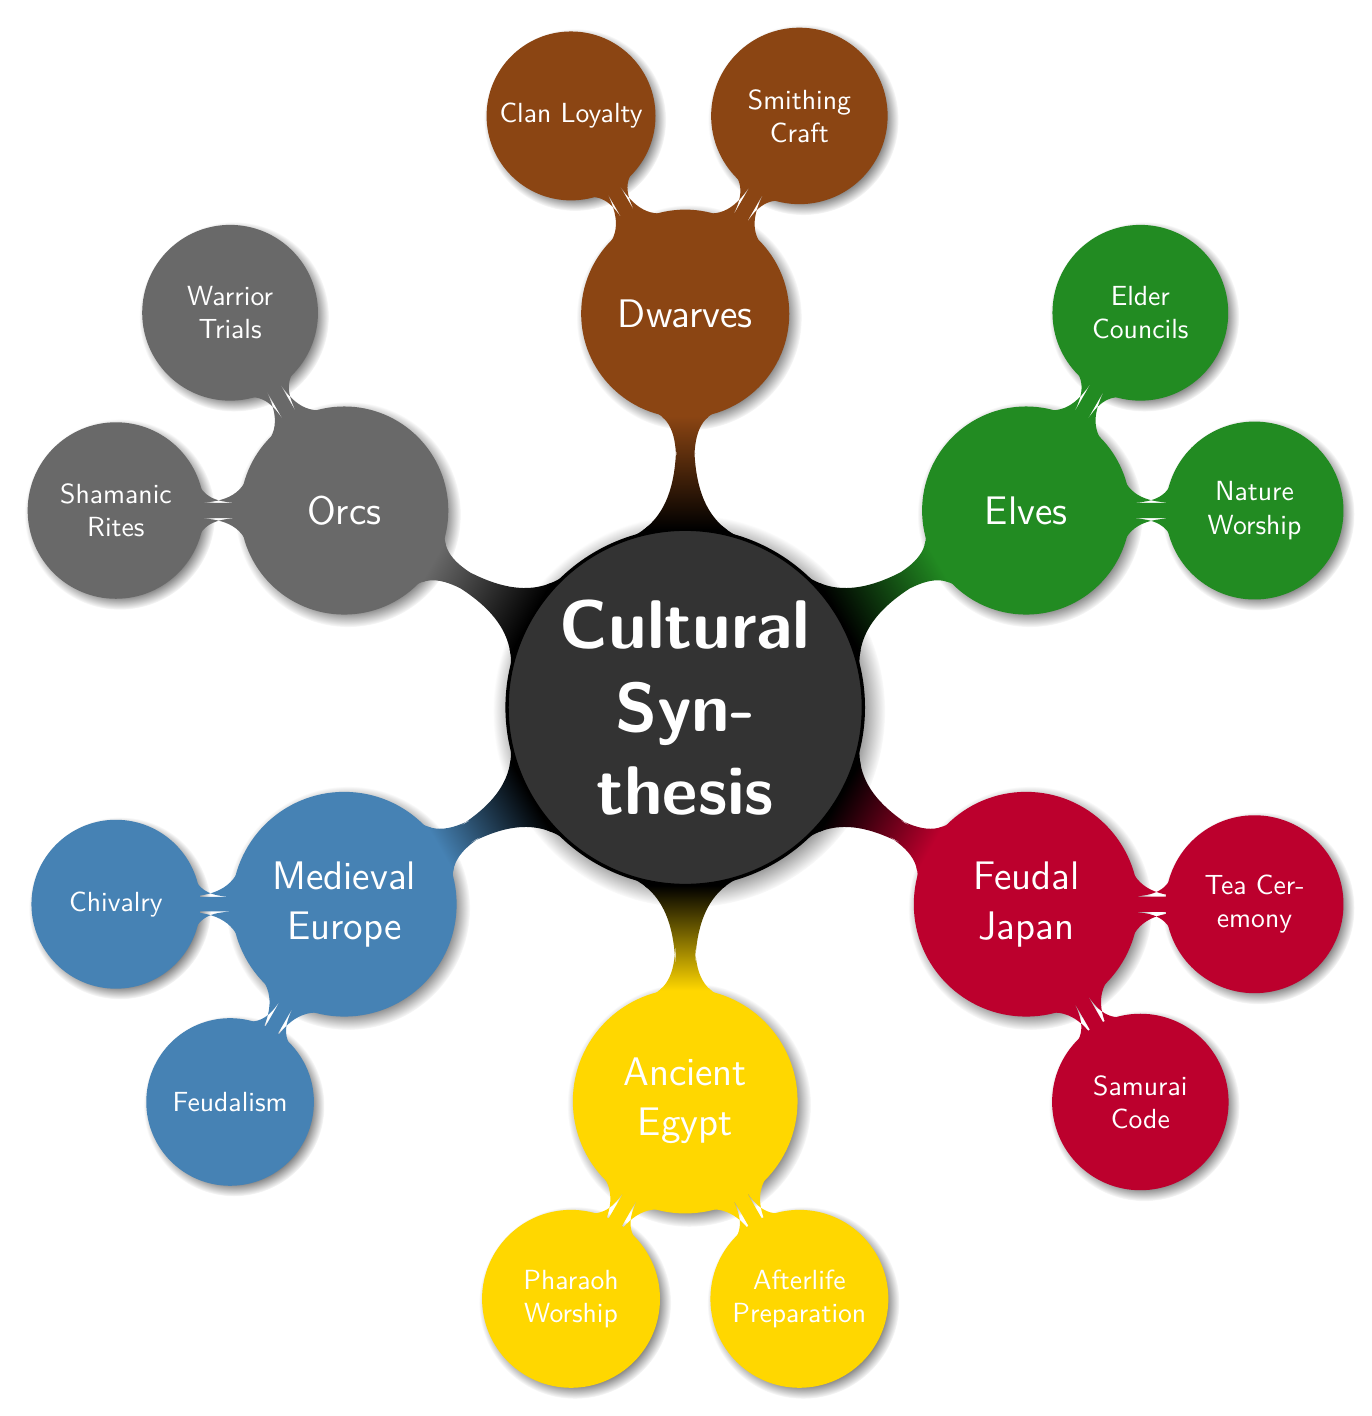What are the two traditions listed under Medieval Europe? The traditions listed under Medieval Europe in the diagram are "Chivalry" and "Feudalism," which can be found by examining the nodes under the Medieval Europe section.
Answer: Chivalry, Feudalism How many cuisine types are there for Ancient Egypt? Under the Ancient Egypt section in the diagram, there are two cuisine types listed: "Bread and Beer" and "Honey Cakes." Counting these nodes gives the answer.
Answer: 2 Which fantasy ethnicity features "Warrior Trials"? The "Warrior Trials" tradition appears under the Orcs section of the diagram. This can be identified by searching through the traditions of each fantasy ethnicity.
Answer: Orcs What is the festival associated with the Dwarves? The Dwarves section lists two festivals: "Forging Day" and "Stonebinding Ritual." Either of these can serve as the answer; one is chosen based on preference.
Answer: Forging Day What is a synthesis example involving Medieval Europe and Elves? The synthesis example involving Medieval Europe and Elves contains traditions such as "Chivalric Nature Knights." This is derived by looking at the Synthesis Examples node related to both Medieval Europe and Elves.
Answer: Chivalric Nature Knights Count the number of nodes under the Feudal Japan section. The Feudal Japan section contains two nodes representing traditions: "Samurai Code" and "Tea Ceremony." Counting these gives the total number of nodes in that section.
Answer: 2 Which cuisine incorporates elements from both Ancient Egypt and Dwarves? The shared cuisine for the synthesis of Ancient Egypt and Dwarves includes "Honey Bread and Beer." This cuisine can be found in the Synthesis Examples related to both cultures.
Answer: Honey Bread and Beer What festival is mentioned for Feudal Japan and Orcs synthesis? The synthesis of Feudal Japan and Orcs has the "Cherry Blossom Battle" festival. This festival node can be found within the combined cultural synthesis example for those two groups.
Answer: Cherry Blossom Battle Identify the two traditions related to Elves. The Elves node lists two traditions, "Nature Worship" and "Elder Councils." This information is easily accessible by examining the Elves section of the diagram.
Answer: Nature Worship, Elder Councils 